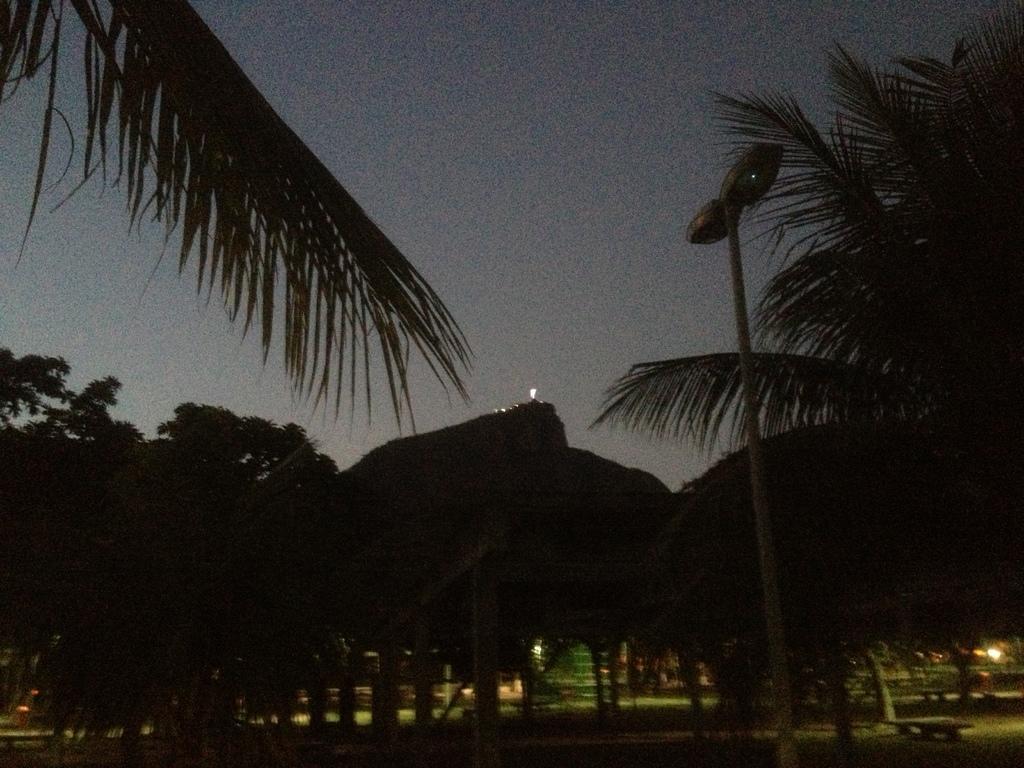Could you give a brief overview of what you see in this image? In this picture, I can see trees and lights to the pole and a cloudy sky and i can see few lights. 